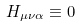Convert formula to latex. <formula><loc_0><loc_0><loc_500><loc_500>H _ { \mu \nu \alpha } \equiv 0</formula> 